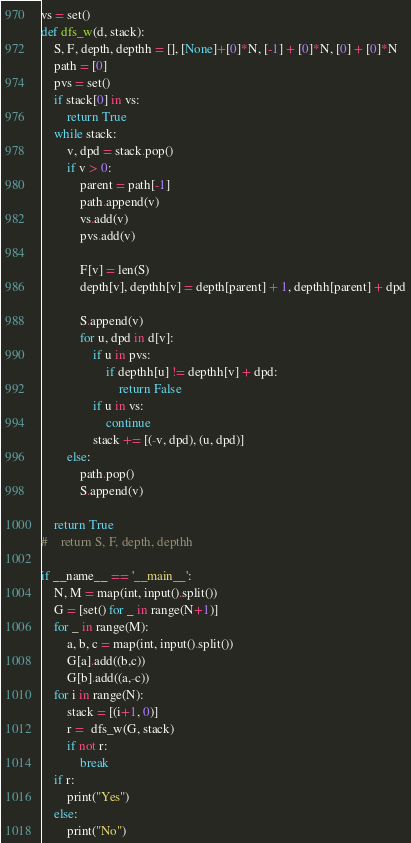Convert code to text. <code><loc_0><loc_0><loc_500><loc_500><_Python_>vs = set()
def dfs_w(d, stack):
    S, F, depth, depthh = [], [None]+[0]*N, [-1] + [0]*N, [0] + [0]*N
    path = [0]
    pvs = set()
    if stack[0] in vs:
        return True
    while stack:
        v, dpd = stack.pop()
        if v > 0:
            parent = path[-1]
            path.append(v)
            vs.add(v)
            pvs.add(v)

            F[v] = len(S)
            depth[v], depthh[v] = depth[parent] + 1, depthh[parent] + dpd

            S.append(v)
            for u, dpd in d[v]:
                if u in pvs:
                    if depthh[u] != depthh[v] + dpd:
                        return False
                if u in vs:
                    continue
                stack += [(-v, dpd), (u, dpd)]
        else:
            path.pop()
            S.append(v)

    return True
#    return S, F, depth, depthh

if __name__ == '__main__':
    N, M = map(int, input().split())
    G = [set() for _ in range(N+1)]
    for _ in range(M):
        a, b, c = map(int, input().split())
        G[a].add((b,c))
        G[b].add((a,-c))
    for i in range(N):
        stack = [(i+1, 0)] 
        r =  dfs_w(G, stack)
        if not r:
            break
    if r:
        print("Yes")
    else:
        print("No")
</code> 